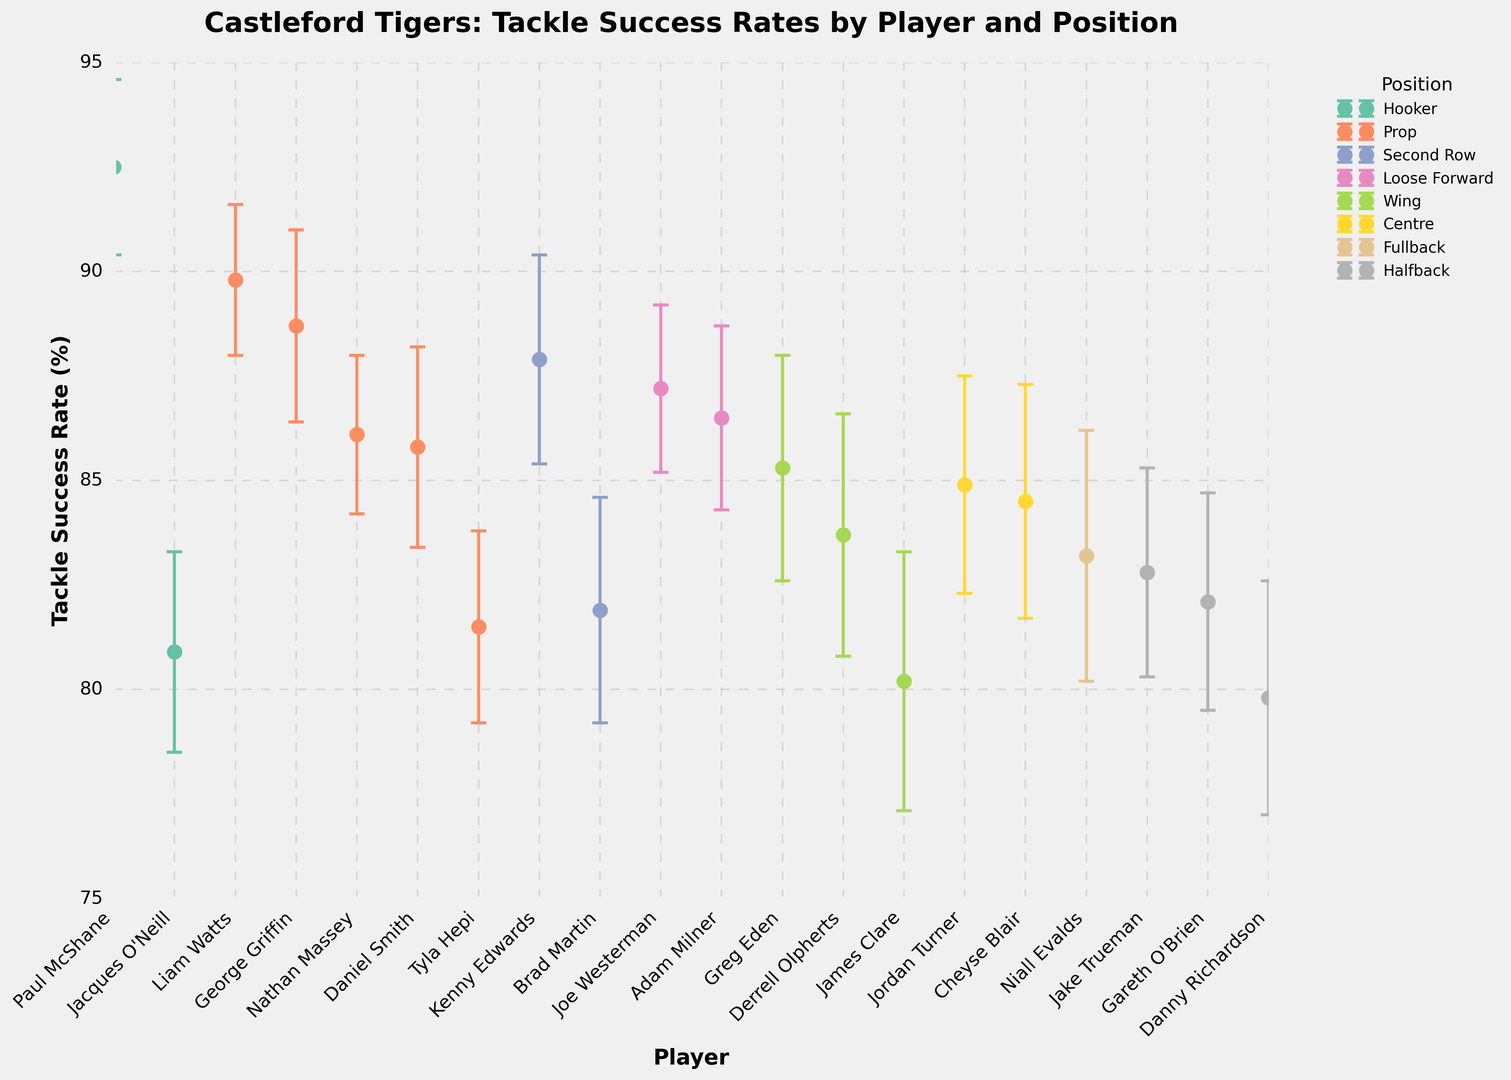What is the tackle success rate of the player with the highest rate? Look for the player with the topmost point on the vertical axis, which appears to be Paul McShane. According to the data, his tackle success rate is 92.5%.
Answer: 92.5% Who is the player with the lowest tackle success rate and what is that rate? Locate the player with the lowest point on the vertical axis, which is Danny Richardson. According to the data, his tackle success rate is 79.8%.
Answer: Danny Richardson, 79.8% Which position has the most players in the top 5 tackle success rates? Identify the top 5 points on the vertical axis and note their colors, which represent different positions. The colors corresponding to these top 5 points are from Hooker (Paul McShane), Prop (Liam Watts and George Griffin), Second Row (Kenny Edwards), and Loose Forward (Joe Westerman). Since Prop appears twice, it has the most players in the top 5.
Answer: Prop What is the average tackle success rate of players in the Prop position? Extract the tackle success rates for all Prop players (89.8, 88.7, 86.1, 85.8, 81.5). Sum these values and then divide by the number of Prop players (5): (89.8 + 88.7 + 86.1 + 85.8 + 81.5) / 5 = 86.38%.
Answer: 86.38% Is there any player in the Wing position with a tackle success rate above 85%? Look for the points colored for the Wing position and see if any of them are above the 85% mark on the vertical axis. Greg Eden has a tackle success rate of 85.3%, which is above 85%.
Answer: Yes, Greg Eden Which position has the highest average tackle success rate? Calculate the average tackle success rate for each position by summing the rates and dividing by the number of players in that position, then compare these averages. Hooker: (92.5 + 80.9) / 2 = 86.7%. Prop: (89.8 + 88.7 + 86.1 + 85.8 + 81.5) / 5 = 86.38%. Second Row: (87.9 + 81.9) / 2 = 84.9%. Loose Forward: (87.2 + 86.5) / 2 = 86.85%. Wing: (85.3 + 83.7 + 80.2) / 3 = 83.07%. Centre: (84.9 + 84.5) / 2 = 84.7%. Fullback: 83.2%. Halfback: (82.8 + 82.1 + 79.8) / 3 = 81.57%. The position with the highest average is Loose Forward with 86.85%.
Answer: Loose Forward Which player has the largest error margin in their tackle success rate? Find the player associated with the longest error bar, which corresponds to the largest error margin in the data provided. According to the data, James Clare has the largest error margin of 3.1%.
Answer: James Clare Is there any position where all players have a tackle success rate above 85%? Visually identify each position and check if all points (players) within that position are above the 85% mark on the vertical axis. For the Prop position, despite some players, such as Tyla Hepi and Daniel Smith, being very close, the total span dips below 85%. No position meets this condition entirely.
Answer: No Comparing the average tackle success rate of Fullback and Halfback positions, which one has a higher rate and by how much? Calculate the average tackle success rate for Fullback and Halfback. Fullback: 83.2%, Halfback: (82.8 + 82.1 + 79.8) / 3 = 81.57%. Subtract the average Halfback rate from the average Fullback rate: 83.2 - 81.57 = 1.63%.
Answer: Fullback by 1.63% 